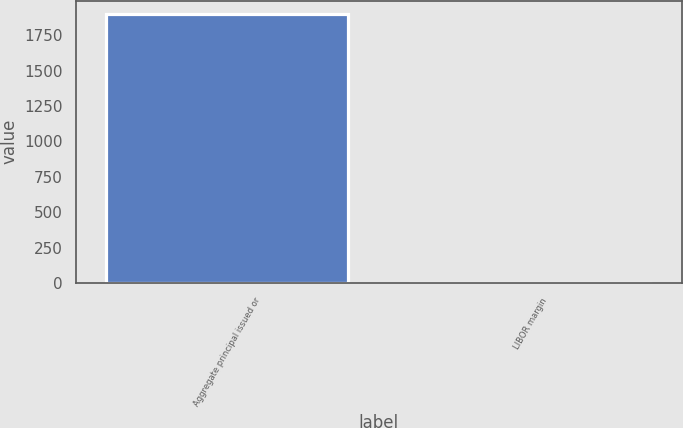Convert chart. <chart><loc_0><loc_0><loc_500><loc_500><bar_chart><fcel>Aggregate principal issued or<fcel>LIBOR margin<nl><fcel>1900<fcel>2<nl></chart> 